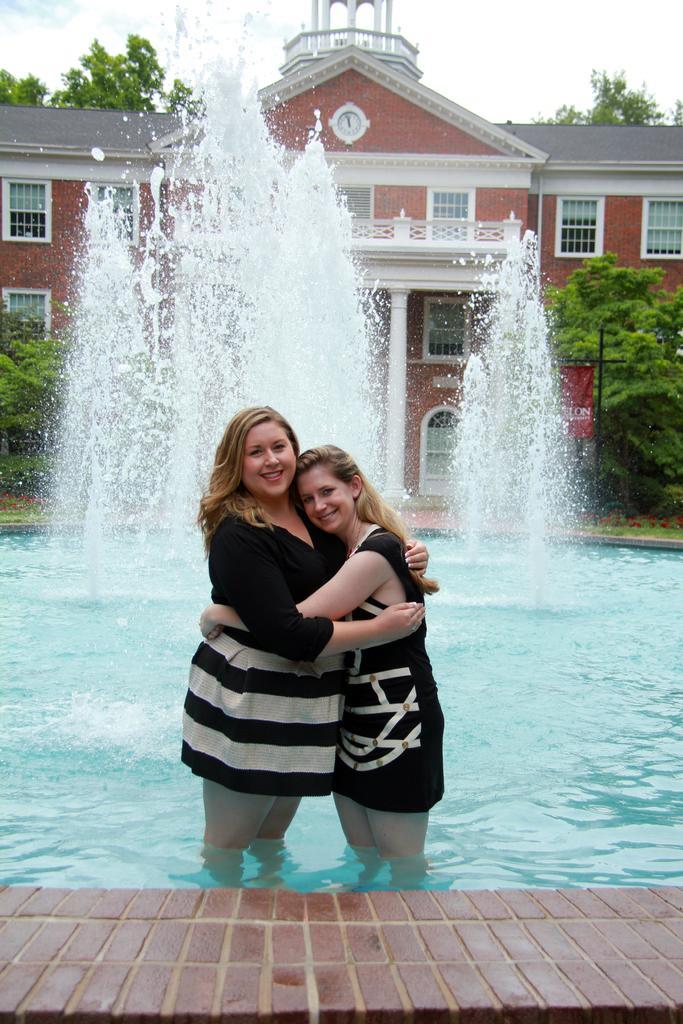Describe this image in one or two sentences. In this image two people are standing in the fountain. At the back side there are trees and building. 